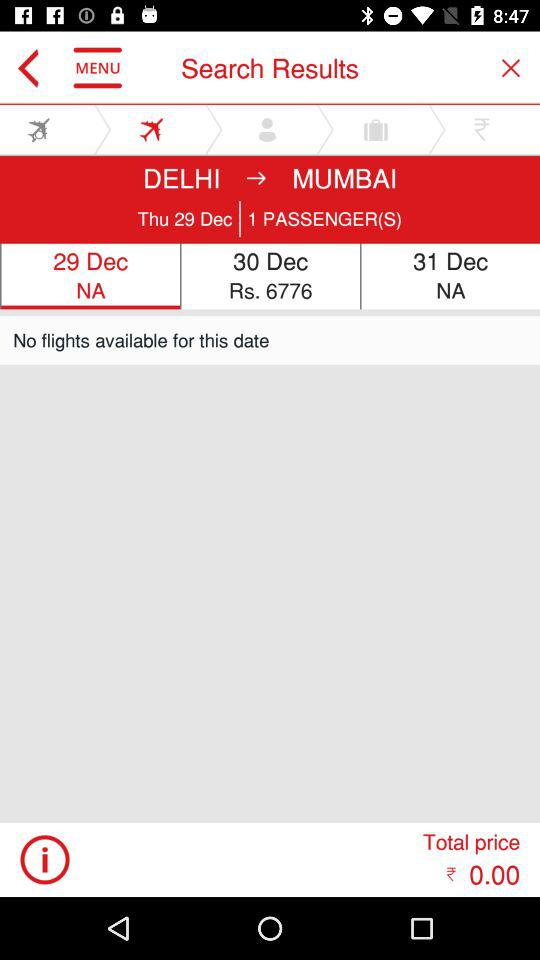What is the total price? The total price is ₹0.00. 